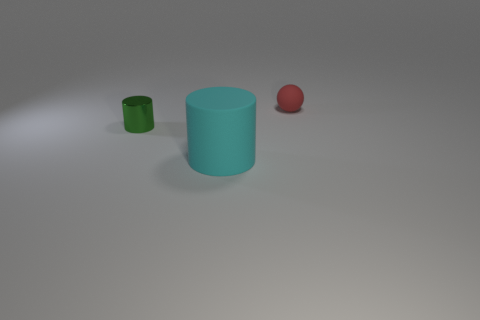Add 1 big cyan matte cylinders. How many objects exist? 4 Subtract all cyan matte cylinders. Subtract all metal things. How many objects are left? 1 Add 2 large cyan matte objects. How many large cyan matte objects are left? 3 Add 1 green cylinders. How many green cylinders exist? 2 Subtract 0 green balls. How many objects are left? 3 Subtract all spheres. How many objects are left? 2 Subtract all brown cylinders. Subtract all brown cubes. How many cylinders are left? 2 